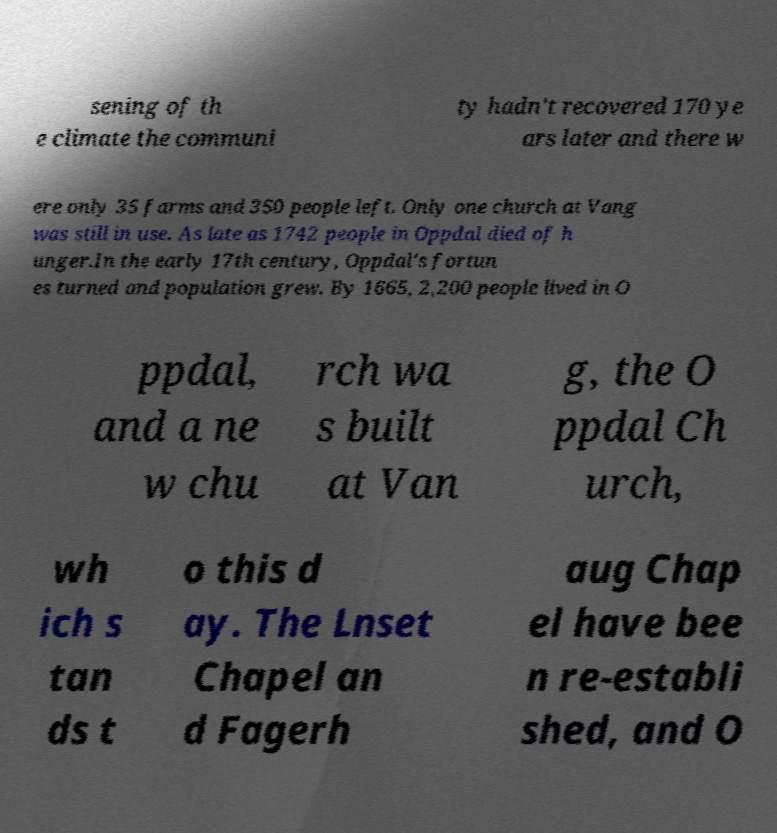Could you extract and type out the text from this image? sening of th e climate the communi ty hadn't recovered 170 ye ars later and there w ere only 35 farms and 350 people left. Only one church at Vang was still in use. As late as 1742 people in Oppdal died of h unger.In the early 17th century, Oppdal's fortun es turned and population grew. By 1665, 2,200 people lived in O ppdal, and a ne w chu rch wa s built at Van g, the O ppdal Ch urch, wh ich s tan ds t o this d ay. The Lnset Chapel an d Fagerh aug Chap el have bee n re-establi shed, and O 